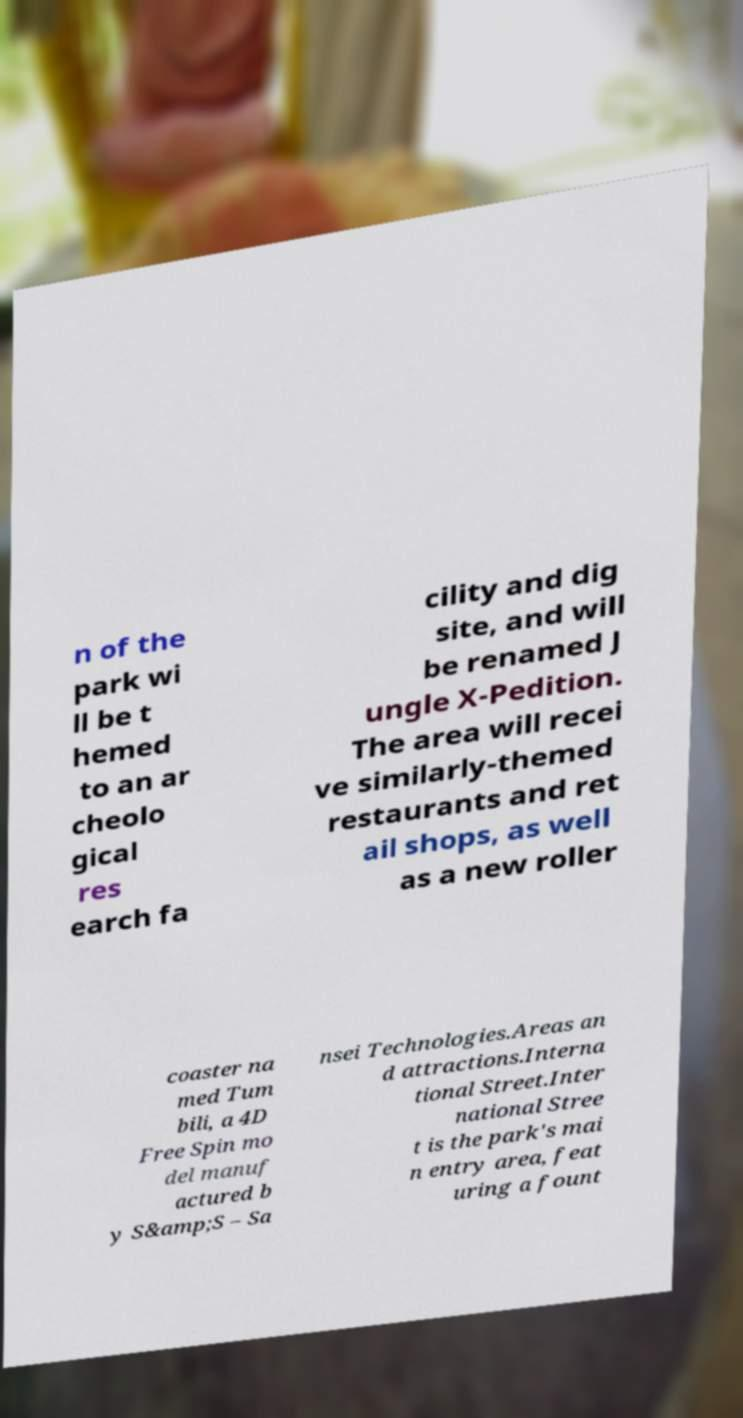There's text embedded in this image that I need extracted. Can you transcribe it verbatim? n of the park wi ll be t hemed to an ar cheolo gical res earch fa cility and dig site, and will be renamed J ungle X-Pedition. The area will recei ve similarly-themed restaurants and ret ail shops, as well as a new roller coaster na med Tum bili, a 4D Free Spin mo del manuf actured b y S&amp;S – Sa nsei Technologies.Areas an d attractions.Interna tional Street.Inter national Stree t is the park's mai n entry area, feat uring a fount 